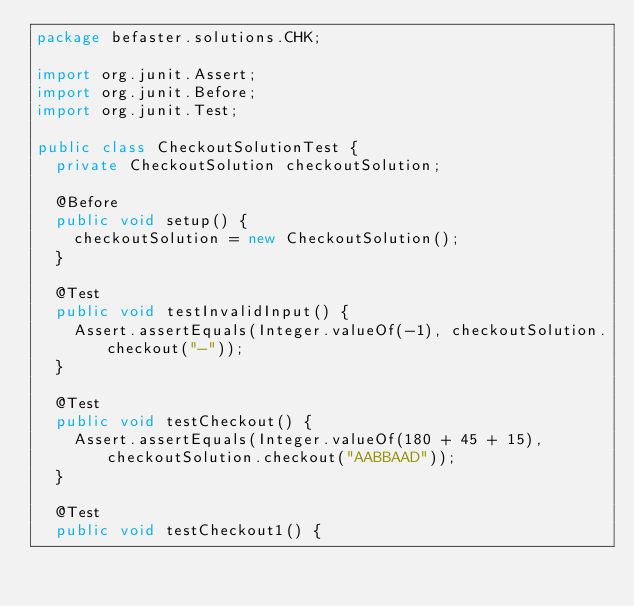<code> <loc_0><loc_0><loc_500><loc_500><_Java_>package befaster.solutions.CHK;

import org.junit.Assert;
import org.junit.Before;
import org.junit.Test;

public class CheckoutSolutionTest {
	private CheckoutSolution checkoutSolution;

	@Before
	public void setup() {
		checkoutSolution = new CheckoutSolution();
	}

	@Test
	public void testInvalidInput() {
		Assert.assertEquals(Integer.valueOf(-1), checkoutSolution.checkout("-"));
	}

	@Test
	public void testCheckout() {
		Assert.assertEquals(Integer.valueOf(180 + 45 + 15), checkoutSolution.checkout("AABBAAD"));
	}

	@Test
	public void testCheckout1() {</code> 